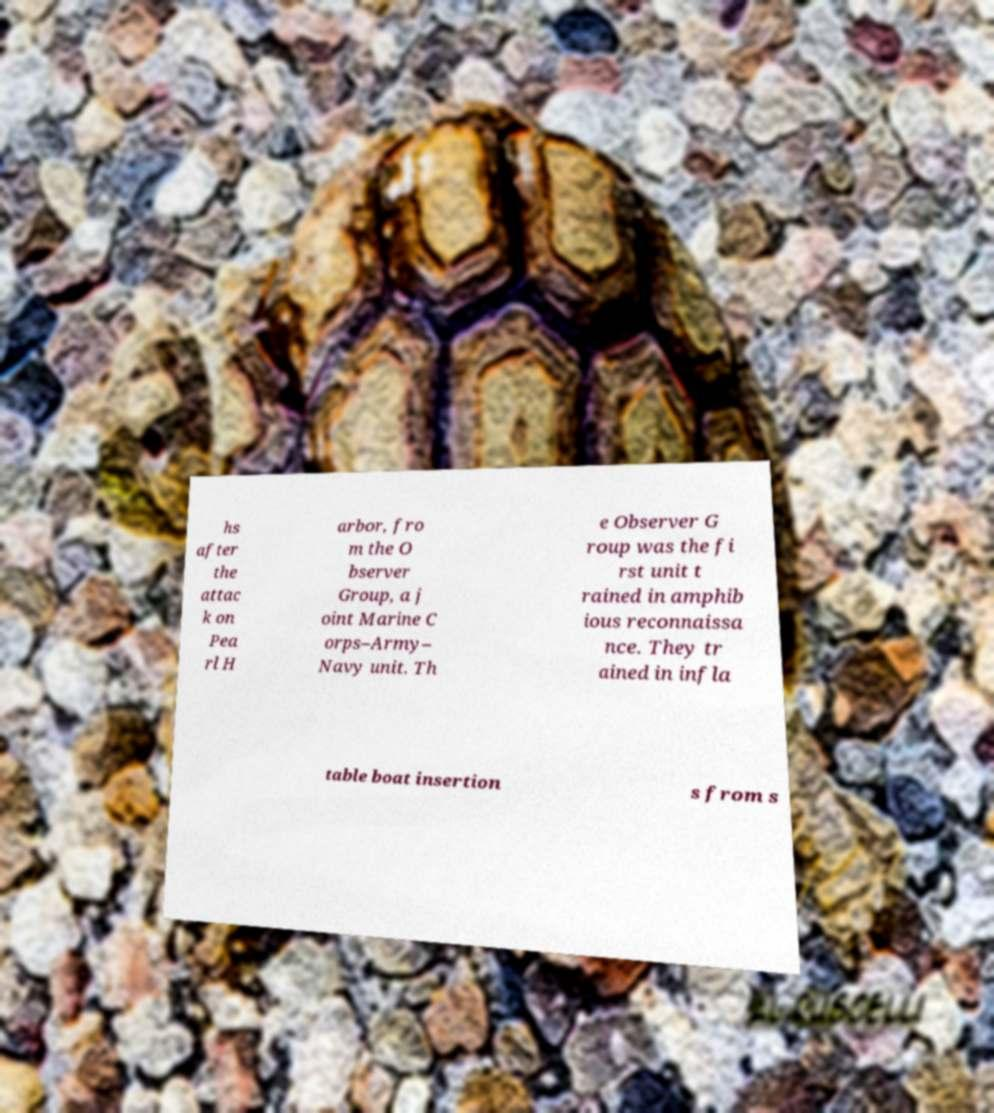For documentation purposes, I need the text within this image transcribed. Could you provide that? hs after the attac k on Pea rl H arbor, fro m the O bserver Group, a j oint Marine C orps–Army– Navy unit. Th e Observer G roup was the fi rst unit t rained in amphib ious reconnaissa nce. They tr ained in infla table boat insertion s from s 